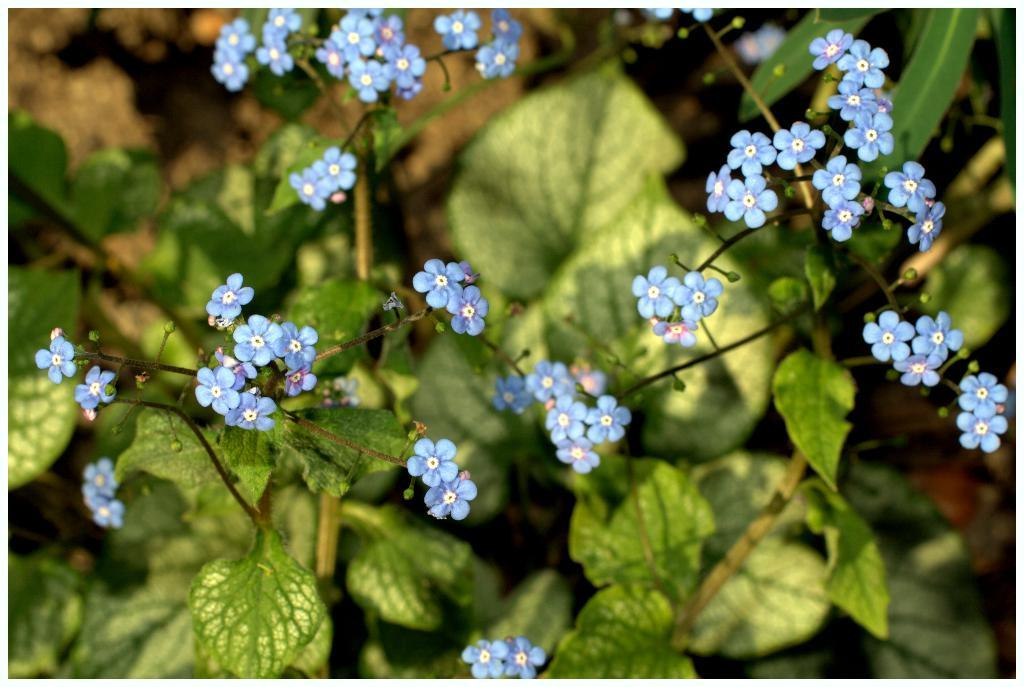What type of living organisms can be seen in the image? Plants can be seen in the image. What additional features can be observed on the plants? The plants have flowers on them. What type of cast can be seen on the plants in the image? There is no cast present on the plants in the image. What kind of pipe is visible in the image? There is no pipe visible in the image; it only features plants with flowers. 